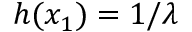<formula> <loc_0><loc_0><loc_500><loc_500>h ( x _ { 1 } ) = 1 / \lambda</formula> 